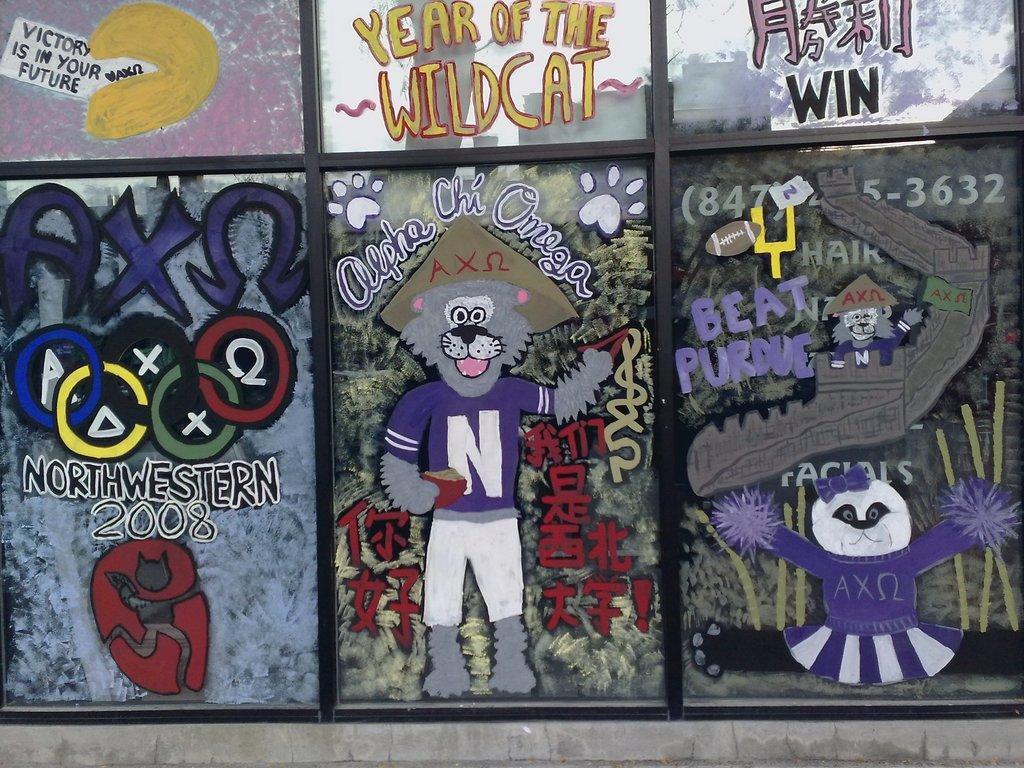How would you summarize this image in a sentence or two? In this image I can see few glass windows. On the glasses I can see few cartoon pictures and I can see something written on the glasses with multi color. 